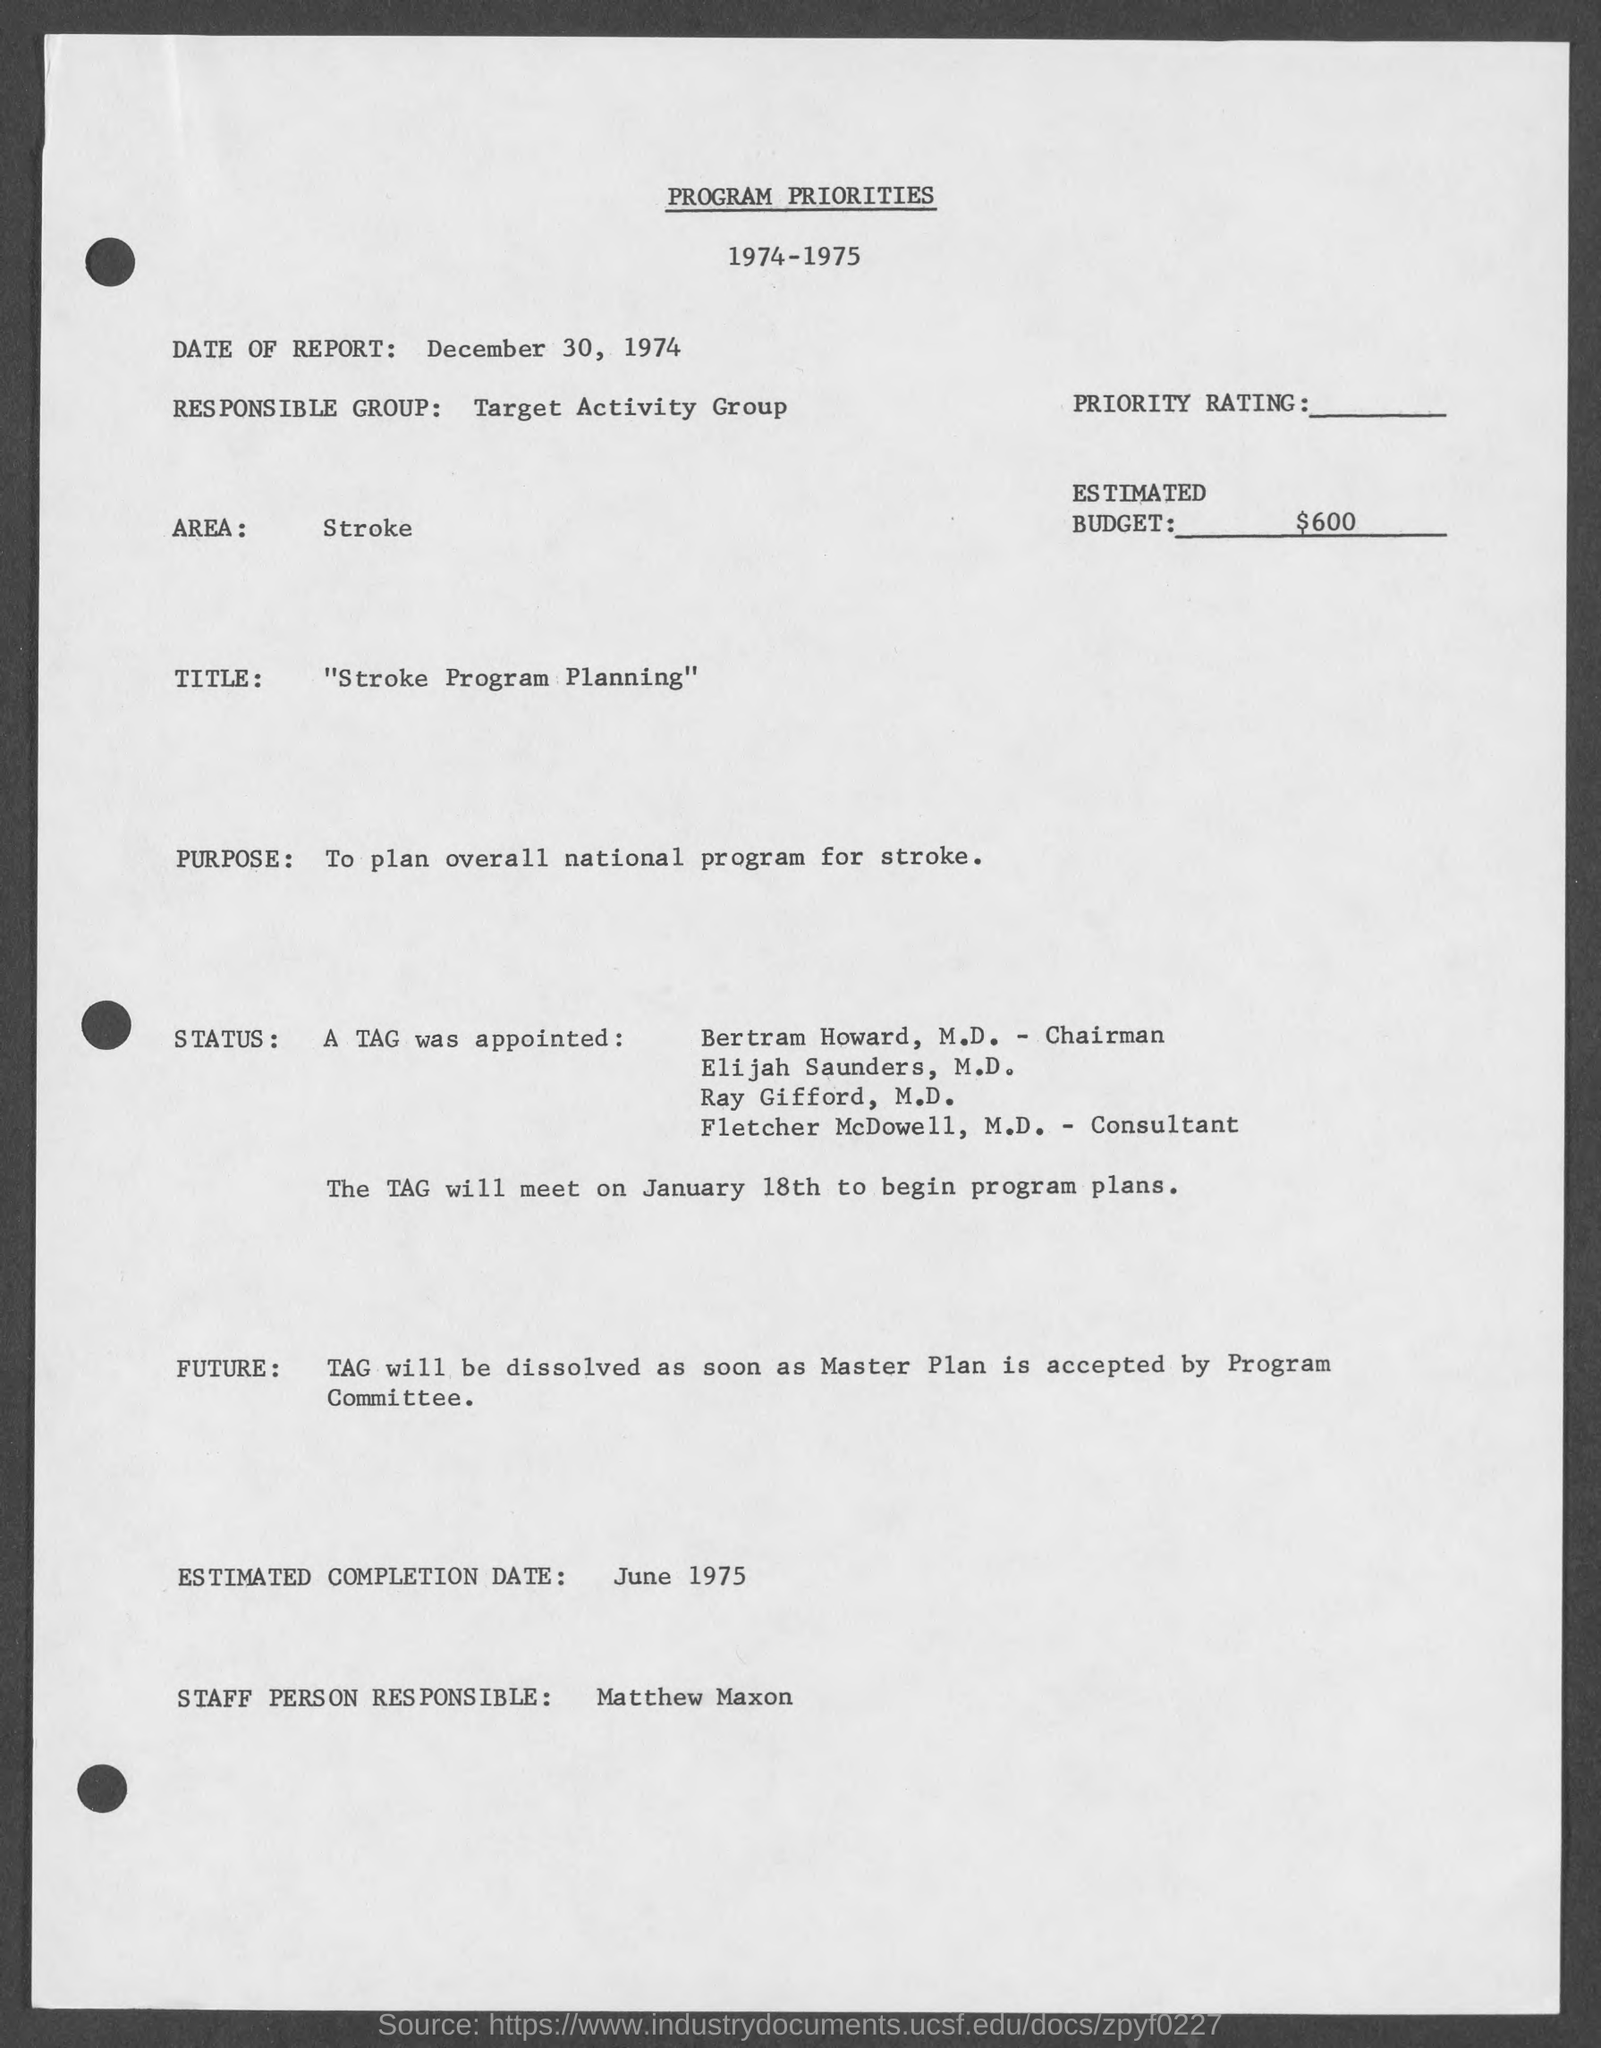What is the date of report ?
Give a very brief answer. DECEMBER 30, 1974. Which is the responsible group?
Give a very brief answer. Target activity group. What is estimated budget ?
Your response must be concise. $600. What is the area ?
Your answer should be very brief. Stroke. What is the title ?
Your answer should be compact. "Stroke Program Planning". What is the purpose ?
Your answer should be very brief. TO PLAN OVERALL NATIONAL PROGRAM FOR STROKE. When is the estimated completion date ?
Offer a terse response. June 1975. Who is the staff person responsible?
Give a very brief answer. MATTHEW MAXON. 